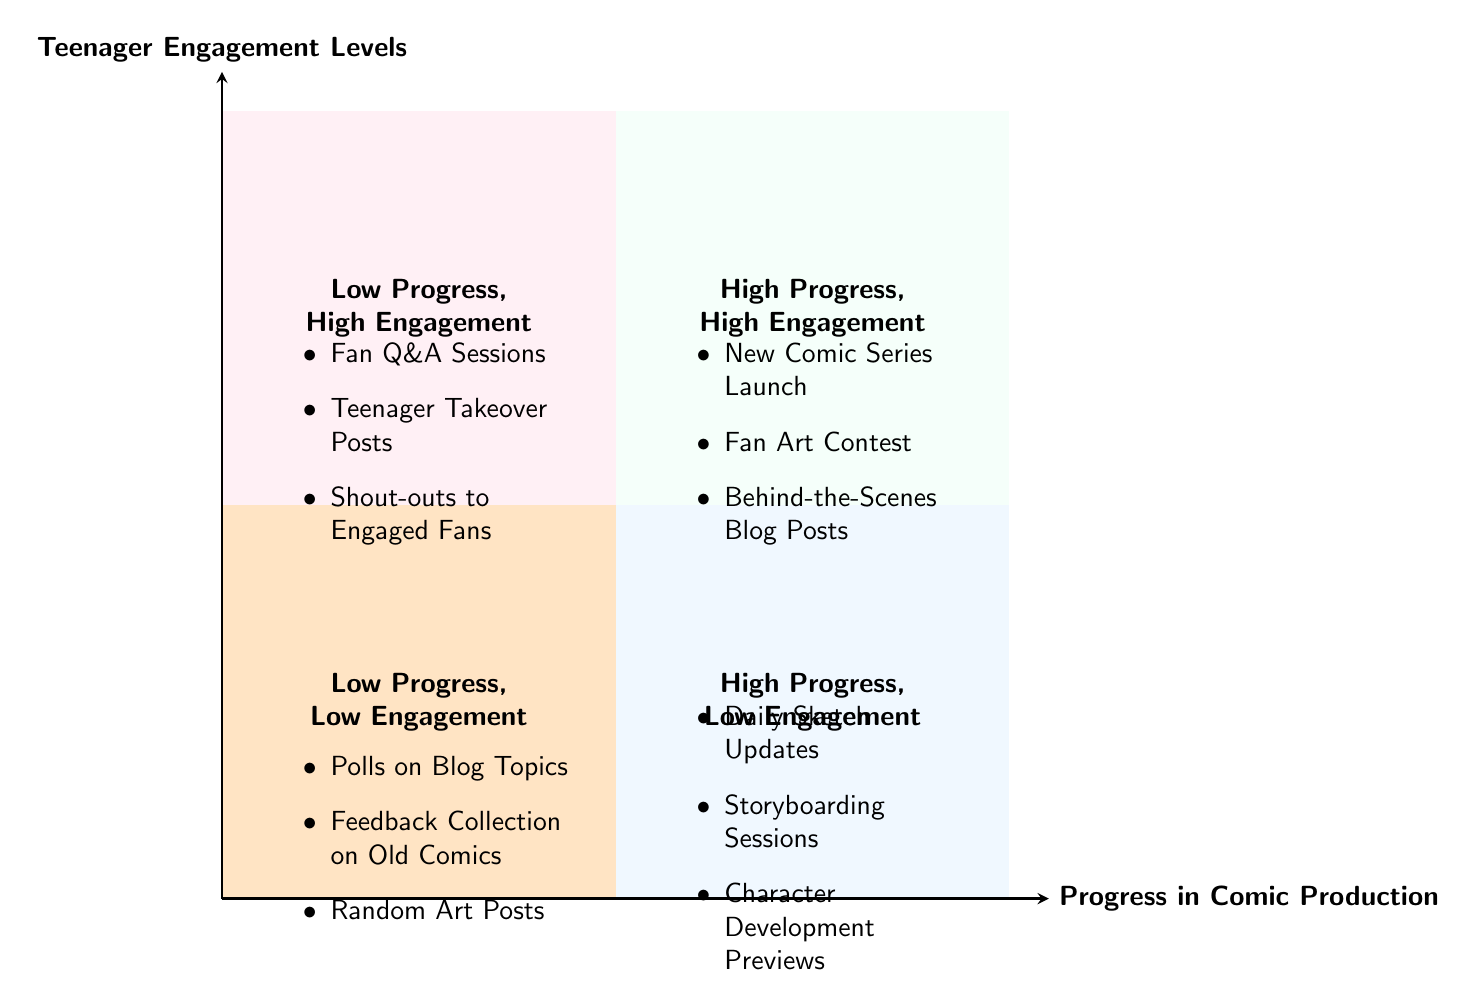What activities are listed in the "High Progress, High Engagement" quadrant? The "High Progress, High Engagement" quadrant includes three activities: New Comic Series Launch, Fan Art Contest, and Behind-the-Scenes Blog Posts. You can find these items noted inside the quadrant's area at the top right of the diagram.
Answer: New Comic Series Launch, Fan Art Contest, Behind-the-Scenes Blog Posts Which quadrant contains "Daily Sketch Updates"? The "Daily Sketch Updates" activity is located in the "High Progress, Low Engagement" quadrant. This can be confirmed by identifying it among the list of activities on the lower right section of the diagram.
Answer: High Progress, Low Engagement How many activities are in the "Low Progress, High Engagement" quadrant? There are three activities listed in the "Low Progress, High Engagement" quadrant: Fan Q&A Sessions, Teenager Takeover Posts, and Shout-outs to Engaged Fans. This can be counted directly from the items in the corresponding area of the diagram.
Answer: 3 Which quadrant would you consider the most ideal for engaging teenagers while producing comics? The most ideal quadrant is the "High Progress, High Engagement" quadrant because it indicates both high engagement levels from teenagers and significant progress in comic production. This evaluation is based on the diagram’s classifications of the activities and their corresponding levels of engagement and progress.
Answer: High Progress, High Engagement What category does "Polls on Blog Topics" fall under? "Polls on Blog Topics" is categorized under the "Low Progress, Low Engagement" quadrant. This is seen as it is listed within the area indicating both low levels of teenager engagement and low levels of comic production progress.
Answer: Low Progress, Low Engagement 